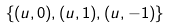<formula> <loc_0><loc_0><loc_500><loc_500>\left \{ ( u , 0 ) , ( u , 1 ) , ( u , - 1 ) \right \}</formula> 